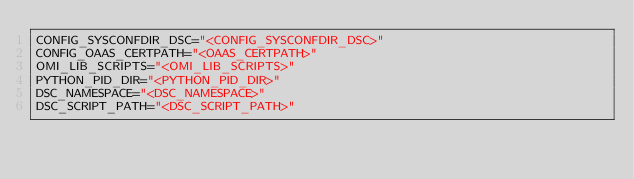<code> <loc_0><loc_0><loc_500><loc_500><_Python_>CONFIG_SYSCONFDIR_DSC="<CONFIG_SYSCONFDIR_DSC>"
CONFIG_OAAS_CERTPATH="<OAAS_CERTPATH>"
OMI_LIB_SCRIPTS="<OMI_LIB_SCRIPTS>"
PYTHON_PID_DIR="<PYTHON_PID_DIR>"
DSC_NAMESPACE="<DSC_NAMESPACE>"
DSC_SCRIPT_PATH="<DSC_SCRIPT_PATH>"
</code> 